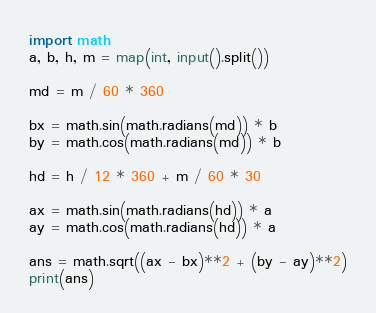Convert code to text. <code><loc_0><loc_0><loc_500><loc_500><_Python_>import math
a, b, h, m = map(int, input().split())

md = m / 60 * 360

bx = math.sin(math.radians(md)) * b
by = math.cos(math.radians(md)) * b

hd = h / 12 * 360 + m / 60 * 30

ax = math.sin(math.radians(hd)) * a
ay = math.cos(math.radians(hd)) * a

ans = math.sqrt((ax - bx)**2 + (by - ay)**2)
print(ans)</code> 